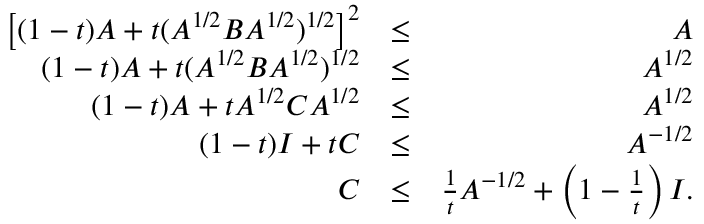Convert formula to latex. <formula><loc_0><loc_0><loc_500><loc_500>\begin{array} { r l r } { \left [ ( 1 - t ) A + t ( A ^ { 1 / 2 } B A ^ { 1 / 2 } ) ^ { 1 / 2 } \right ] ^ { 2 } } & { \leq } & { A } \\ { ( 1 - t ) A + t ( A ^ { 1 / 2 } B A ^ { 1 / 2 } ) ^ { 1 / 2 } } & { \leq } & { A ^ { 1 / 2 } } \\ { ( 1 - t ) A + t A ^ { 1 / 2 } C A ^ { 1 / 2 } } & { \leq } & { A ^ { 1 / 2 } } \\ { ( 1 - t ) I + t C } & { \leq } & { A ^ { - 1 / 2 } } \\ { C } & { \leq } & { \frac { 1 } { t } A ^ { - 1 / 2 } + \left ( 1 - \frac { 1 } { t } \right ) I . } \end{array}</formula> 